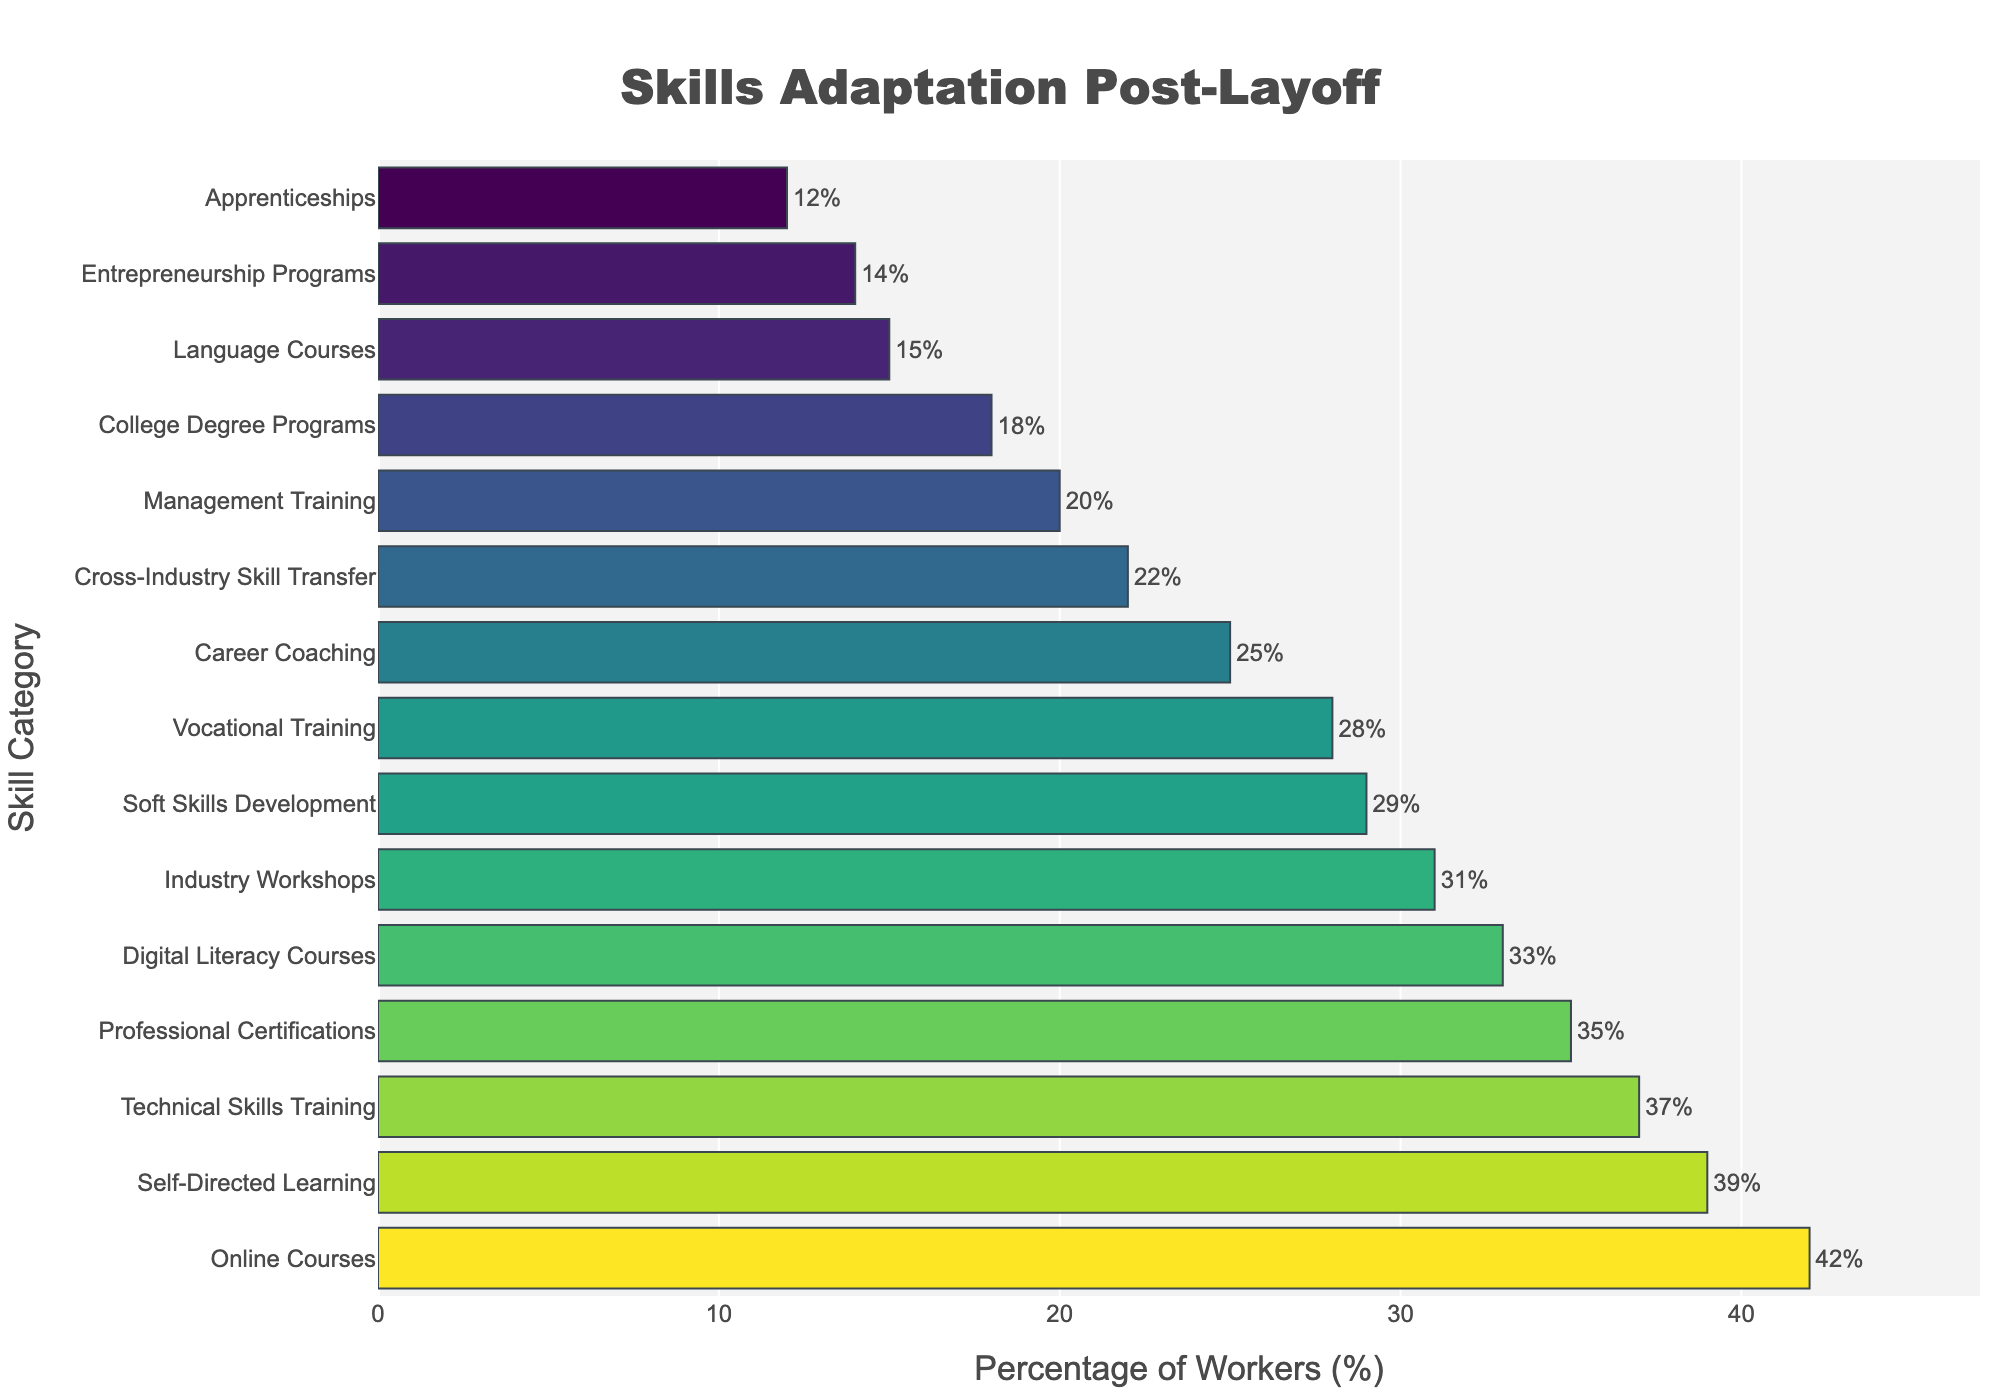What's the most popular skill category pursued by workers post-layoff? The most popular skill category is the one with the highest percentage on the horizontal bar chart. In the figure, "Online Courses" has the highest percentage at 42%, making it the most popular.
Answer: Online Courses Which skill category has the lowest percentage of workers? The skill category with the lowest percentage is the one with the smallest horizontal bar. In the chart, "Apprenticeships" has the smallest percentage at 12%.
Answer: Apprenticeships How much more popular is "Online Courses" compared to "Apprenticeships"? To find the difference, subtract the percentage of "Apprenticeships" from "Online Courses". The percentages are 42% for "Online Courses" and 12% for "Apprenticeships". Therefore, the difference is 42% - 12% = 30%.
Answer: 30% Which skill categories have a percentage of workers over 30%? By examining the lengths of the bars and their corresponding percentages, we identify "Online Courses" (42%), "Professional Certifications" (35%), "Industry Workshops" (31%), "Self-Directed Learning" (39%), and "Technical Skills Training" (37%).
Answer: Online Courses, Professional Certifications, Industry Workshops, Self-Directed Learning, Technical Skills Training Are more workers pursuing "Digital Literacy Courses" or "Management Training"? By comparing the lengths of the bars for these two categories, "Digital Literacy Courses" has a percentage of 33%, while "Management Training" has 20%. Therefore, more workers are pursuing "Digital Literacy Courses".
Answer: Digital Literacy Courses Calculate the average percentage of workers pursuing "Vocational Training" and "Career Coaching". Add the percentages of "Vocational Training" (28%) and "Career Coaching" (25%), then divide by 2. The calculation is (28% + 25%) / 2 = 53% / 2 = 26.5%.
Answer: 26.5% Which skill category has exactly one-third of the percentage for "Online Courses"? One-third of the percentage for "Online Courses" (42%) is calculated as 42% / 3 = 14%. The skill category with a percentage closest to 14% is "Entrepreneurship Programs" at 14%.
Answer: Entrepreneurship Programs How much higher is the percentage for "Self-Directed Learning" compared to "Language Courses"? Subtract the percentage of "Language Courses" from "Self-Directed Learning". The percentages are 39% for "Self-Directed Learning" and 15% for "Language Courses". Therefore, the difference is 39% - 15% = 24%.
Answer: 24% Which skill category has a percentage of workers closest to the median percentage? To find the median, list all percentages in ascending order: 12, 14, 15, 18, 20, 22, 25, 28, 29, 31, 33, 35, 37, 39, 42. The median value is the 8th value, which is "Vocational Training" at 28%. Thus, the median percentage is 28%.
Answer: Vocational Training 